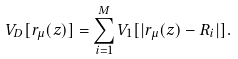Convert formula to latex. <formula><loc_0><loc_0><loc_500><loc_500>V _ { D } [ { r } _ { \mu } ( z ) ] = \sum _ { i = 1 } ^ { M } V _ { 1 } [ | { r } _ { \mu } ( z ) - { R } _ { i } | ] .</formula> 